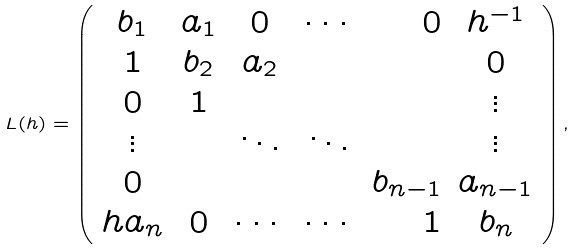Convert formula to latex. <formula><loc_0><loc_0><loc_500><loc_500>L ( h ) = \left ( \begin{array} { c c c c r c } b _ { 1 } & a _ { 1 } & 0 & \cdots & 0 & h ^ { - 1 } \\ 1 & b _ { 2 } & a _ { 2 } & & & 0 \\ 0 & 1 & & & & \vdots \\ \vdots & & \ddots & \ddots & & \vdots \\ 0 & & & & b _ { n - 1 } & a _ { n - 1 } \\ h a _ { n } & 0 & \cdots & \cdots & 1 & b _ { n } \end{array} \right ) ,</formula> 